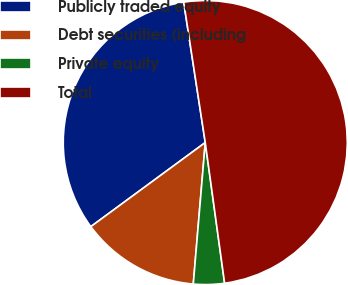Convert chart. <chart><loc_0><loc_0><loc_500><loc_500><pie_chart><fcel>Publicly traded equity<fcel>Debt securities (including<fcel>Private equity<fcel>Total<nl><fcel>32.66%<fcel>13.57%<fcel>3.52%<fcel>50.25%<nl></chart> 